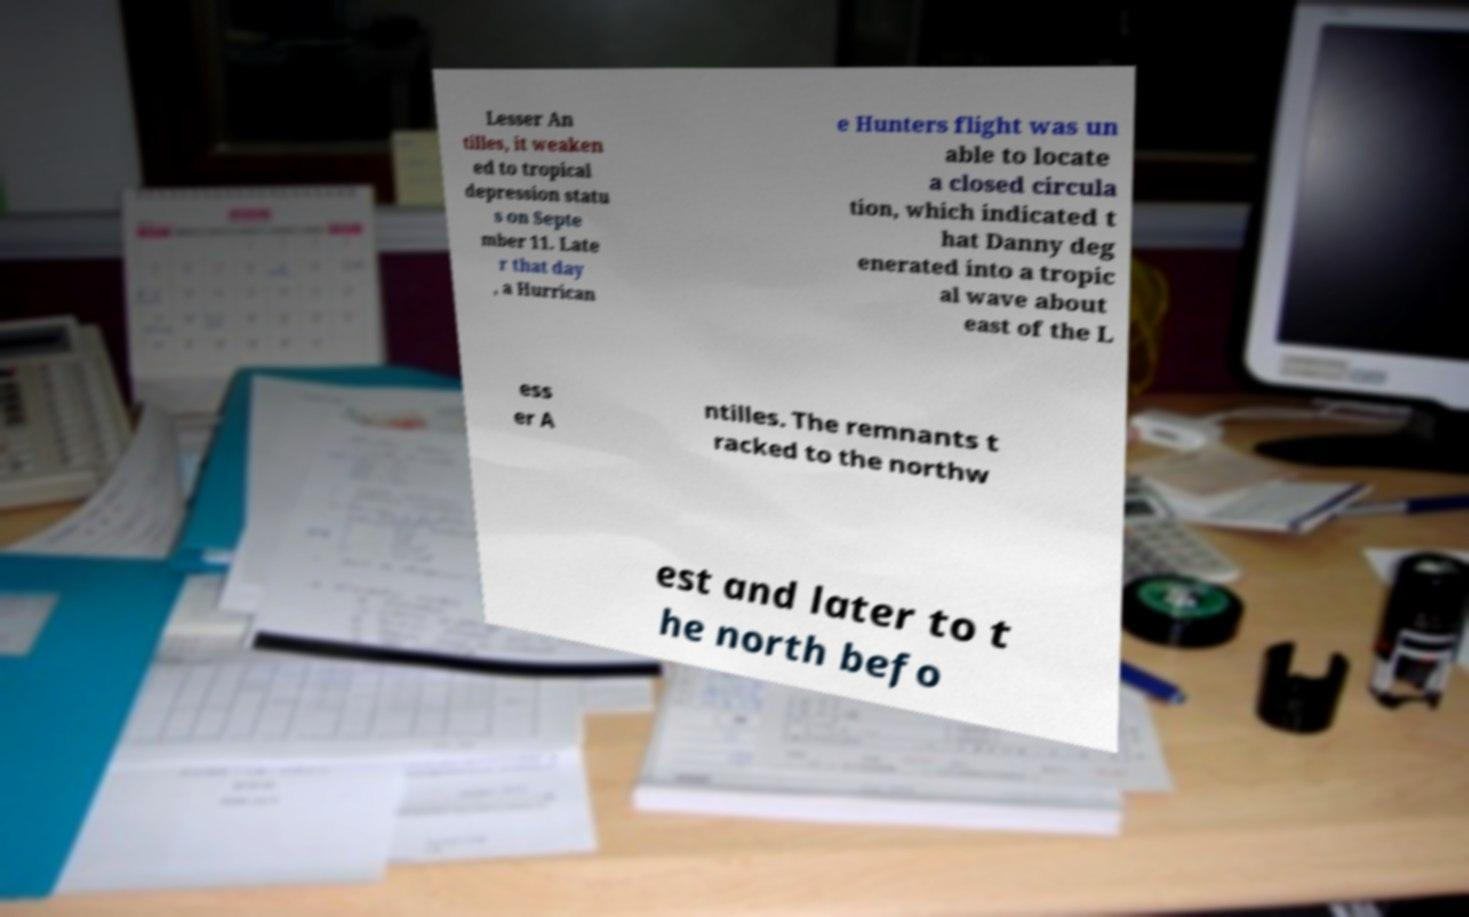Could you extract and type out the text from this image? Lesser An tilles, it weaken ed to tropical depression statu s on Septe mber 11. Late r that day , a Hurrican e Hunters flight was un able to locate a closed circula tion, which indicated t hat Danny deg enerated into a tropic al wave about east of the L ess er A ntilles. The remnants t racked to the northw est and later to t he north befo 